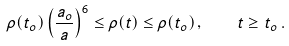<formula> <loc_0><loc_0><loc_500><loc_500>\rho ( t _ { o } ) \left ( \frac { a _ { o } } { a } \right ) ^ { 6 } \leq \rho ( t ) \leq \rho ( t _ { o } ) \, , \quad t \geq t _ { o } \, .</formula> 